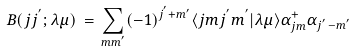<formula> <loc_0><loc_0><loc_500><loc_500>B ( j j ^ { ^ { \prime } } ; \lambda \mu ) \, = \, \sum _ { m m ^ { ^ { \prime } } } ( - 1 ) ^ { j ^ { ^ { \prime } } + m { ^ { \prime } } } \langle j m j ^ { ^ { \prime } } m ^ { ^ { \prime } } | \lambda \mu \rangle \alpha _ { j m } ^ { + } \alpha _ { j ^ { ^ { \prime } } - m ^ { ^ { \prime } } }</formula> 